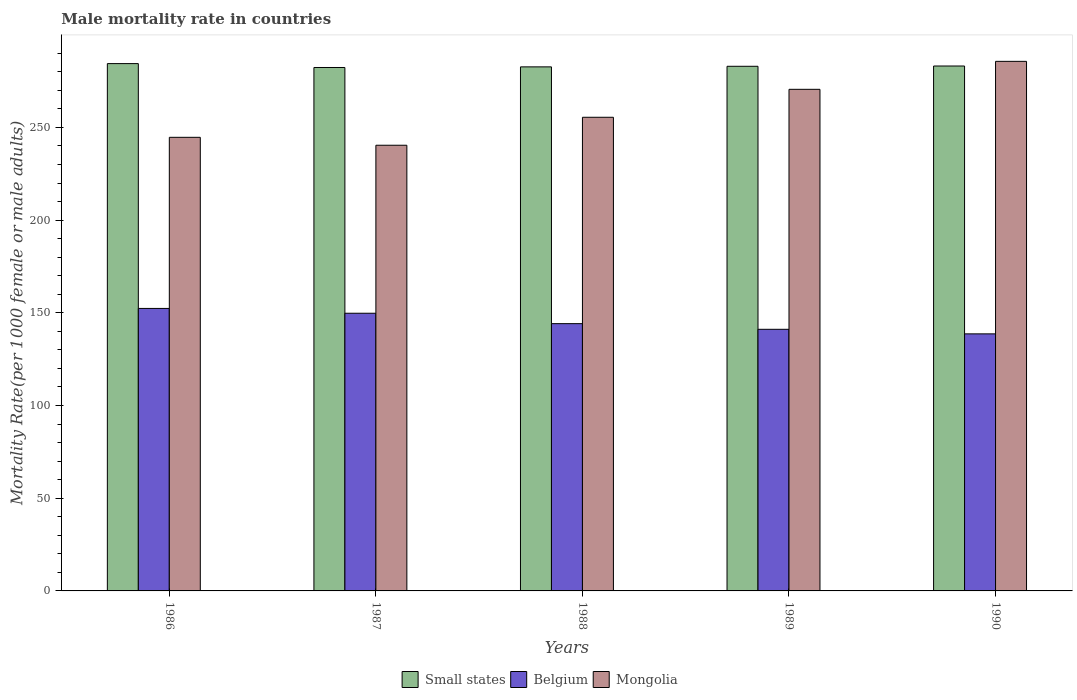How many groups of bars are there?
Keep it short and to the point. 5. Are the number of bars per tick equal to the number of legend labels?
Keep it short and to the point. Yes. Are the number of bars on each tick of the X-axis equal?
Your response must be concise. Yes. How many bars are there on the 3rd tick from the left?
Ensure brevity in your answer.  3. How many bars are there on the 5th tick from the right?
Give a very brief answer. 3. In how many cases, is the number of bars for a given year not equal to the number of legend labels?
Your response must be concise. 0. What is the male mortality rate in Mongolia in 1987?
Offer a very short reply. 240.4. Across all years, what is the maximum male mortality rate in Mongolia?
Offer a very short reply. 285.65. Across all years, what is the minimum male mortality rate in Small states?
Your answer should be very brief. 282.34. In which year was the male mortality rate in Belgium minimum?
Provide a succinct answer. 1990. What is the total male mortality rate in Small states in the graph?
Provide a short and direct response. 1415.58. What is the difference between the male mortality rate in Small states in 1987 and that in 1990?
Offer a terse response. -0.8. What is the difference between the male mortality rate in Mongolia in 1986 and the male mortality rate in Small states in 1988?
Offer a very short reply. -38. What is the average male mortality rate in Belgium per year?
Your answer should be compact. 145.22. In the year 1990, what is the difference between the male mortality rate in Mongolia and male mortality rate in Belgium?
Ensure brevity in your answer.  147. In how many years, is the male mortality rate in Mongolia greater than 100?
Make the answer very short. 5. What is the ratio of the male mortality rate in Small states in 1987 to that in 1988?
Ensure brevity in your answer.  1. Is the difference between the male mortality rate in Mongolia in 1988 and 1990 greater than the difference between the male mortality rate in Belgium in 1988 and 1990?
Provide a short and direct response. No. What is the difference between the highest and the second highest male mortality rate in Small states?
Provide a succinct answer. 1.29. What is the difference between the highest and the lowest male mortality rate in Belgium?
Provide a succinct answer. 13.72. What does the 3rd bar from the right in 1986 represents?
Ensure brevity in your answer.  Small states. Is it the case that in every year, the sum of the male mortality rate in Mongolia and male mortality rate in Belgium is greater than the male mortality rate in Small states?
Your response must be concise. Yes. Are all the bars in the graph horizontal?
Make the answer very short. No. How many years are there in the graph?
Your answer should be compact. 5. What is the difference between two consecutive major ticks on the Y-axis?
Your response must be concise. 50. Are the values on the major ticks of Y-axis written in scientific E-notation?
Provide a short and direct response. No. Does the graph contain any zero values?
Keep it short and to the point. No. Where does the legend appear in the graph?
Make the answer very short. Bottom center. How are the legend labels stacked?
Give a very brief answer. Horizontal. What is the title of the graph?
Offer a terse response. Male mortality rate in countries. What is the label or title of the Y-axis?
Your answer should be very brief. Mortality Rate(per 1000 female or male adults). What is the Mortality Rate(per 1000 female or male adults) in Small states in 1986?
Provide a short and direct response. 284.43. What is the Mortality Rate(per 1000 female or male adults) of Belgium in 1986?
Give a very brief answer. 152.38. What is the Mortality Rate(per 1000 female or male adults) in Mongolia in 1986?
Provide a succinct answer. 244.67. What is the Mortality Rate(per 1000 female or male adults) in Small states in 1987?
Your answer should be compact. 282.34. What is the Mortality Rate(per 1000 female or male adults) in Belgium in 1987?
Your answer should be compact. 149.78. What is the Mortality Rate(per 1000 female or male adults) in Mongolia in 1987?
Offer a very short reply. 240.4. What is the Mortality Rate(per 1000 female or male adults) in Small states in 1988?
Your answer should be compact. 282.67. What is the Mortality Rate(per 1000 female or male adults) in Belgium in 1988?
Your response must be concise. 144.16. What is the Mortality Rate(per 1000 female or male adults) of Mongolia in 1988?
Give a very brief answer. 255.49. What is the Mortality Rate(per 1000 female or male adults) in Small states in 1989?
Your response must be concise. 282.99. What is the Mortality Rate(per 1000 female or male adults) of Belgium in 1989?
Offer a very short reply. 141.12. What is the Mortality Rate(per 1000 female or male adults) of Mongolia in 1989?
Ensure brevity in your answer.  270.57. What is the Mortality Rate(per 1000 female or male adults) of Small states in 1990?
Make the answer very short. 283.14. What is the Mortality Rate(per 1000 female or male adults) in Belgium in 1990?
Make the answer very short. 138.65. What is the Mortality Rate(per 1000 female or male adults) in Mongolia in 1990?
Your answer should be very brief. 285.65. Across all years, what is the maximum Mortality Rate(per 1000 female or male adults) of Small states?
Make the answer very short. 284.43. Across all years, what is the maximum Mortality Rate(per 1000 female or male adults) in Belgium?
Offer a very short reply. 152.38. Across all years, what is the maximum Mortality Rate(per 1000 female or male adults) of Mongolia?
Your answer should be very brief. 285.65. Across all years, what is the minimum Mortality Rate(per 1000 female or male adults) in Small states?
Your answer should be very brief. 282.34. Across all years, what is the minimum Mortality Rate(per 1000 female or male adults) of Belgium?
Provide a succinct answer. 138.65. Across all years, what is the minimum Mortality Rate(per 1000 female or male adults) in Mongolia?
Your answer should be compact. 240.4. What is the total Mortality Rate(per 1000 female or male adults) of Small states in the graph?
Keep it short and to the point. 1415.58. What is the total Mortality Rate(per 1000 female or male adults) of Belgium in the graph?
Keep it short and to the point. 726.09. What is the total Mortality Rate(per 1000 female or male adults) in Mongolia in the graph?
Give a very brief answer. 1296.78. What is the difference between the Mortality Rate(per 1000 female or male adults) of Small states in 1986 and that in 1987?
Offer a terse response. 2.09. What is the difference between the Mortality Rate(per 1000 female or male adults) of Belgium in 1986 and that in 1987?
Make the answer very short. 2.6. What is the difference between the Mortality Rate(per 1000 female or male adults) of Mongolia in 1986 and that in 1987?
Provide a short and direct response. 4.27. What is the difference between the Mortality Rate(per 1000 female or male adults) in Small states in 1986 and that in 1988?
Ensure brevity in your answer.  1.76. What is the difference between the Mortality Rate(per 1000 female or male adults) in Belgium in 1986 and that in 1988?
Provide a succinct answer. 8.21. What is the difference between the Mortality Rate(per 1000 female or male adults) of Mongolia in 1986 and that in 1988?
Offer a very short reply. -10.81. What is the difference between the Mortality Rate(per 1000 female or male adults) of Small states in 1986 and that in 1989?
Provide a short and direct response. 1.45. What is the difference between the Mortality Rate(per 1000 female or male adults) of Belgium in 1986 and that in 1989?
Your answer should be very brief. 11.26. What is the difference between the Mortality Rate(per 1000 female or male adults) of Mongolia in 1986 and that in 1989?
Keep it short and to the point. -25.9. What is the difference between the Mortality Rate(per 1000 female or male adults) in Small states in 1986 and that in 1990?
Offer a very short reply. 1.29. What is the difference between the Mortality Rate(per 1000 female or male adults) of Belgium in 1986 and that in 1990?
Your answer should be very brief. 13.72. What is the difference between the Mortality Rate(per 1000 female or male adults) in Mongolia in 1986 and that in 1990?
Give a very brief answer. -40.98. What is the difference between the Mortality Rate(per 1000 female or male adults) of Small states in 1987 and that in 1988?
Offer a terse response. -0.33. What is the difference between the Mortality Rate(per 1000 female or male adults) in Belgium in 1987 and that in 1988?
Your answer should be very brief. 5.62. What is the difference between the Mortality Rate(per 1000 female or male adults) of Mongolia in 1987 and that in 1988?
Your answer should be very brief. -15.08. What is the difference between the Mortality Rate(per 1000 female or male adults) in Small states in 1987 and that in 1989?
Offer a very short reply. -0.64. What is the difference between the Mortality Rate(per 1000 female or male adults) of Belgium in 1987 and that in 1989?
Your answer should be compact. 8.66. What is the difference between the Mortality Rate(per 1000 female or male adults) in Mongolia in 1987 and that in 1989?
Your answer should be compact. -30.16. What is the difference between the Mortality Rate(per 1000 female or male adults) in Small states in 1987 and that in 1990?
Make the answer very short. -0.8. What is the difference between the Mortality Rate(per 1000 female or male adults) in Belgium in 1987 and that in 1990?
Offer a very short reply. 11.12. What is the difference between the Mortality Rate(per 1000 female or male adults) of Mongolia in 1987 and that in 1990?
Ensure brevity in your answer.  -45.25. What is the difference between the Mortality Rate(per 1000 female or male adults) of Small states in 1988 and that in 1989?
Ensure brevity in your answer.  -0.31. What is the difference between the Mortality Rate(per 1000 female or male adults) in Belgium in 1988 and that in 1989?
Provide a short and direct response. 3.05. What is the difference between the Mortality Rate(per 1000 female or male adults) of Mongolia in 1988 and that in 1989?
Offer a very short reply. -15.08. What is the difference between the Mortality Rate(per 1000 female or male adults) of Small states in 1988 and that in 1990?
Your answer should be compact. -0.47. What is the difference between the Mortality Rate(per 1000 female or male adults) of Belgium in 1988 and that in 1990?
Keep it short and to the point. 5.51. What is the difference between the Mortality Rate(per 1000 female or male adults) in Mongolia in 1988 and that in 1990?
Your answer should be very brief. -30.16. What is the difference between the Mortality Rate(per 1000 female or male adults) of Small states in 1989 and that in 1990?
Provide a short and direct response. -0.15. What is the difference between the Mortality Rate(per 1000 female or male adults) in Belgium in 1989 and that in 1990?
Keep it short and to the point. 2.46. What is the difference between the Mortality Rate(per 1000 female or male adults) of Mongolia in 1989 and that in 1990?
Provide a short and direct response. -15.08. What is the difference between the Mortality Rate(per 1000 female or male adults) in Small states in 1986 and the Mortality Rate(per 1000 female or male adults) in Belgium in 1987?
Provide a succinct answer. 134.66. What is the difference between the Mortality Rate(per 1000 female or male adults) of Small states in 1986 and the Mortality Rate(per 1000 female or male adults) of Mongolia in 1987?
Offer a terse response. 44.03. What is the difference between the Mortality Rate(per 1000 female or male adults) in Belgium in 1986 and the Mortality Rate(per 1000 female or male adults) in Mongolia in 1987?
Provide a succinct answer. -88.03. What is the difference between the Mortality Rate(per 1000 female or male adults) of Small states in 1986 and the Mortality Rate(per 1000 female or male adults) of Belgium in 1988?
Ensure brevity in your answer.  140.27. What is the difference between the Mortality Rate(per 1000 female or male adults) of Small states in 1986 and the Mortality Rate(per 1000 female or male adults) of Mongolia in 1988?
Keep it short and to the point. 28.95. What is the difference between the Mortality Rate(per 1000 female or male adults) of Belgium in 1986 and the Mortality Rate(per 1000 female or male adults) of Mongolia in 1988?
Keep it short and to the point. -103.11. What is the difference between the Mortality Rate(per 1000 female or male adults) in Small states in 1986 and the Mortality Rate(per 1000 female or male adults) in Belgium in 1989?
Offer a very short reply. 143.32. What is the difference between the Mortality Rate(per 1000 female or male adults) in Small states in 1986 and the Mortality Rate(per 1000 female or male adults) in Mongolia in 1989?
Your answer should be very brief. 13.87. What is the difference between the Mortality Rate(per 1000 female or male adults) of Belgium in 1986 and the Mortality Rate(per 1000 female or male adults) of Mongolia in 1989?
Give a very brief answer. -118.19. What is the difference between the Mortality Rate(per 1000 female or male adults) in Small states in 1986 and the Mortality Rate(per 1000 female or male adults) in Belgium in 1990?
Keep it short and to the point. 145.78. What is the difference between the Mortality Rate(per 1000 female or male adults) of Small states in 1986 and the Mortality Rate(per 1000 female or male adults) of Mongolia in 1990?
Ensure brevity in your answer.  -1.22. What is the difference between the Mortality Rate(per 1000 female or male adults) in Belgium in 1986 and the Mortality Rate(per 1000 female or male adults) in Mongolia in 1990?
Ensure brevity in your answer.  -133.28. What is the difference between the Mortality Rate(per 1000 female or male adults) in Small states in 1987 and the Mortality Rate(per 1000 female or male adults) in Belgium in 1988?
Provide a succinct answer. 138.18. What is the difference between the Mortality Rate(per 1000 female or male adults) in Small states in 1987 and the Mortality Rate(per 1000 female or male adults) in Mongolia in 1988?
Your response must be concise. 26.86. What is the difference between the Mortality Rate(per 1000 female or male adults) of Belgium in 1987 and the Mortality Rate(per 1000 female or male adults) of Mongolia in 1988?
Offer a very short reply. -105.71. What is the difference between the Mortality Rate(per 1000 female or male adults) of Small states in 1987 and the Mortality Rate(per 1000 female or male adults) of Belgium in 1989?
Provide a short and direct response. 141.23. What is the difference between the Mortality Rate(per 1000 female or male adults) in Small states in 1987 and the Mortality Rate(per 1000 female or male adults) in Mongolia in 1989?
Keep it short and to the point. 11.77. What is the difference between the Mortality Rate(per 1000 female or male adults) of Belgium in 1987 and the Mortality Rate(per 1000 female or male adults) of Mongolia in 1989?
Your response must be concise. -120.79. What is the difference between the Mortality Rate(per 1000 female or male adults) of Small states in 1987 and the Mortality Rate(per 1000 female or male adults) of Belgium in 1990?
Your answer should be compact. 143.69. What is the difference between the Mortality Rate(per 1000 female or male adults) in Small states in 1987 and the Mortality Rate(per 1000 female or male adults) in Mongolia in 1990?
Give a very brief answer. -3.31. What is the difference between the Mortality Rate(per 1000 female or male adults) in Belgium in 1987 and the Mortality Rate(per 1000 female or male adults) in Mongolia in 1990?
Make the answer very short. -135.87. What is the difference between the Mortality Rate(per 1000 female or male adults) in Small states in 1988 and the Mortality Rate(per 1000 female or male adults) in Belgium in 1989?
Give a very brief answer. 141.56. What is the difference between the Mortality Rate(per 1000 female or male adults) of Small states in 1988 and the Mortality Rate(per 1000 female or male adults) of Mongolia in 1989?
Ensure brevity in your answer.  12.11. What is the difference between the Mortality Rate(per 1000 female or male adults) in Belgium in 1988 and the Mortality Rate(per 1000 female or male adults) in Mongolia in 1989?
Give a very brief answer. -126.4. What is the difference between the Mortality Rate(per 1000 female or male adults) of Small states in 1988 and the Mortality Rate(per 1000 female or male adults) of Belgium in 1990?
Your response must be concise. 144.02. What is the difference between the Mortality Rate(per 1000 female or male adults) of Small states in 1988 and the Mortality Rate(per 1000 female or male adults) of Mongolia in 1990?
Your response must be concise. -2.98. What is the difference between the Mortality Rate(per 1000 female or male adults) of Belgium in 1988 and the Mortality Rate(per 1000 female or male adults) of Mongolia in 1990?
Provide a succinct answer. -141.49. What is the difference between the Mortality Rate(per 1000 female or male adults) in Small states in 1989 and the Mortality Rate(per 1000 female or male adults) in Belgium in 1990?
Offer a very short reply. 144.33. What is the difference between the Mortality Rate(per 1000 female or male adults) in Small states in 1989 and the Mortality Rate(per 1000 female or male adults) in Mongolia in 1990?
Ensure brevity in your answer.  -2.67. What is the difference between the Mortality Rate(per 1000 female or male adults) of Belgium in 1989 and the Mortality Rate(per 1000 female or male adults) of Mongolia in 1990?
Offer a very short reply. -144.53. What is the average Mortality Rate(per 1000 female or male adults) of Small states per year?
Make the answer very short. 283.12. What is the average Mortality Rate(per 1000 female or male adults) of Belgium per year?
Offer a very short reply. 145.22. What is the average Mortality Rate(per 1000 female or male adults) of Mongolia per year?
Provide a short and direct response. 259.36. In the year 1986, what is the difference between the Mortality Rate(per 1000 female or male adults) in Small states and Mortality Rate(per 1000 female or male adults) in Belgium?
Ensure brevity in your answer.  132.06. In the year 1986, what is the difference between the Mortality Rate(per 1000 female or male adults) in Small states and Mortality Rate(per 1000 female or male adults) in Mongolia?
Give a very brief answer. 39.76. In the year 1986, what is the difference between the Mortality Rate(per 1000 female or male adults) of Belgium and Mortality Rate(per 1000 female or male adults) of Mongolia?
Ensure brevity in your answer.  -92.3. In the year 1987, what is the difference between the Mortality Rate(per 1000 female or male adults) of Small states and Mortality Rate(per 1000 female or male adults) of Belgium?
Make the answer very short. 132.56. In the year 1987, what is the difference between the Mortality Rate(per 1000 female or male adults) in Small states and Mortality Rate(per 1000 female or male adults) in Mongolia?
Provide a short and direct response. 41.94. In the year 1987, what is the difference between the Mortality Rate(per 1000 female or male adults) of Belgium and Mortality Rate(per 1000 female or male adults) of Mongolia?
Your response must be concise. -90.62. In the year 1988, what is the difference between the Mortality Rate(per 1000 female or male adults) of Small states and Mortality Rate(per 1000 female or male adults) of Belgium?
Offer a very short reply. 138.51. In the year 1988, what is the difference between the Mortality Rate(per 1000 female or male adults) of Small states and Mortality Rate(per 1000 female or male adults) of Mongolia?
Offer a terse response. 27.19. In the year 1988, what is the difference between the Mortality Rate(per 1000 female or male adults) of Belgium and Mortality Rate(per 1000 female or male adults) of Mongolia?
Your response must be concise. -111.32. In the year 1989, what is the difference between the Mortality Rate(per 1000 female or male adults) in Small states and Mortality Rate(per 1000 female or male adults) in Belgium?
Offer a very short reply. 141.87. In the year 1989, what is the difference between the Mortality Rate(per 1000 female or male adults) in Small states and Mortality Rate(per 1000 female or male adults) in Mongolia?
Make the answer very short. 12.42. In the year 1989, what is the difference between the Mortality Rate(per 1000 female or male adults) of Belgium and Mortality Rate(per 1000 female or male adults) of Mongolia?
Provide a succinct answer. -129.45. In the year 1990, what is the difference between the Mortality Rate(per 1000 female or male adults) of Small states and Mortality Rate(per 1000 female or male adults) of Belgium?
Your answer should be compact. 144.49. In the year 1990, what is the difference between the Mortality Rate(per 1000 female or male adults) in Small states and Mortality Rate(per 1000 female or male adults) in Mongolia?
Offer a terse response. -2.51. In the year 1990, what is the difference between the Mortality Rate(per 1000 female or male adults) of Belgium and Mortality Rate(per 1000 female or male adults) of Mongolia?
Your answer should be compact. -147. What is the ratio of the Mortality Rate(per 1000 female or male adults) of Small states in 1986 to that in 1987?
Your response must be concise. 1.01. What is the ratio of the Mortality Rate(per 1000 female or male adults) of Belgium in 1986 to that in 1987?
Your response must be concise. 1.02. What is the ratio of the Mortality Rate(per 1000 female or male adults) in Mongolia in 1986 to that in 1987?
Offer a very short reply. 1.02. What is the ratio of the Mortality Rate(per 1000 female or male adults) in Small states in 1986 to that in 1988?
Keep it short and to the point. 1.01. What is the ratio of the Mortality Rate(per 1000 female or male adults) in Belgium in 1986 to that in 1988?
Your answer should be compact. 1.06. What is the ratio of the Mortality Rate(per 1000 female or male adults) of Mongolia in 1986 to that in 1988?
Keep it short and to the point. 0.96. What is the ratio of the Mortality Rate(per 1000 female or male adults) in Belgium in 1986 to that in 1989?
Your answer should be very brief. 1.08. What is the ratio of the Mortality Rate(per 1000 female or male adults) of Mongolia in 1986 to that in 1989?
Offer a terse response. 0.9. What is the ratio of the Mortality Rate(per 1000 female or male adults) of Small states in 1986 to that in 1990?
Provide a succinct answer. 1. What is the ratio of the Mortality Rate(per 1000 female or male adults) in Belgium in 1986 to that in 1990?
Give a very brief answer. 1.1. What is the ratio of the Mortality Rate(per 1000 female or male adults) in Mongolia in 1986 to that in 1990?
Offer a terse response. 0.86. What is the ratio of the Mortality Rate(per 1000 female or male adults) of Small states in 1987 to that in 1988?
Keep it short and to the point. 1. What is the ratio of the Mortality Rate(per 1000 female or male adults) of Belgium in 1987 to that in 1988?
Offer a terse response. 1.04. What is the ratio of the Mortality Rate(per 1000 female or male adults) in Mongolia in 1987 to that in 1988?
Ensure brevity in your answer.  0.94. What is the ratio of the Mortality Rate(per 1000 female or male adults) in Belgium in 1987 to that in 1989?
Make the answer very short. 1.06. What is the ratio of the Mortality Rate(per 1000 female or male adults) in Mongolia in 1987 to that in 1989?
Your response must be concise. 0.89. What is the ratio of the Mortality Rate(per 1000 female or male adults) of Small states in 1987 to that in 1990?
Keep it short and to the point. 1. What is the ratio of the Mortality Rate(per 1000 female or male adults) of Belgium in 1987 to that in 1990?
Provide a short and direct response. 1.08. What is the ratio of the Mortality Rate(per 1000 female or male adults) in Mongolia in 1987 to that in 1990?
Offer a very short reply. 0.84. What is the ratio of the Mortality Rate(per 1000 female or male adults) of Belgium in 1988 to that in 1989?
Make the answer very short. 1.02. What is the ratio of the Mortality Rate(per 1000 female or male adults) of Mongolia in 1988 to that in 1989?
Ensure brevity in your answer.  0.94. What is the ratio of the Mortality Rate(per 1000 female or male adults) in Small states in 1988 to that in 1990?
Offer a terse response. 1. What is the ratio of the Mortality Rate(per 1000 female or male adults) in Belgium in 1988 to that in 1990?
Your response must be concise. 1.04. What is the ratio of the Mortality Rate(per 1000 female or male adults) in Mongolia in 1988 to that in 1990?
Ensure brevity in your answer.  0.89. What is the ratio of the Mortality Rate(per 1000 female or male adults) of Small states in 1989 to that in 1990?
Make the answer very short. 1. What is the ratio of the Mortality Rate(per 1000 female or male adults) of Belgium in 1989 to that in 1990?
Your answer should be very brief. 1.02. What is the ratio of the Mortality Rate(per 1000 female or male adults) of Mongolia in 1989 to that in 1990?
Ensure brevity in your answer.  0.95. What is the difference between the highest and the second highest Mortality Rate(per 1000 female or male adults) in Small states?
Your answer should be compact. 1.29. What is the difference between the highest and the second highest Mortality Rate(per 1000 female or male adults) in Belgium?
Offer a very short reply. 2.6. What is the difference between the highest and the second highest Mortality Rate(per 1000 female or male adults) of Mongolia?
Your answer should be compact. 15.08. What is the difference between the highest and the lowest Mortality Rate(per 1000 female or male adults) in Small states?
Offer a terse response. 2.09. What is the difference between the highest and the lowest Mortality Rate(per 1000 female or male adults) of Belgium?
Provide a succinct answer. 13.72. What is the difference between the highest and the lowest Mortality Rate(per 1000 female or male adults) of Mongolia?
Keep it short and to the point. 45.25. 